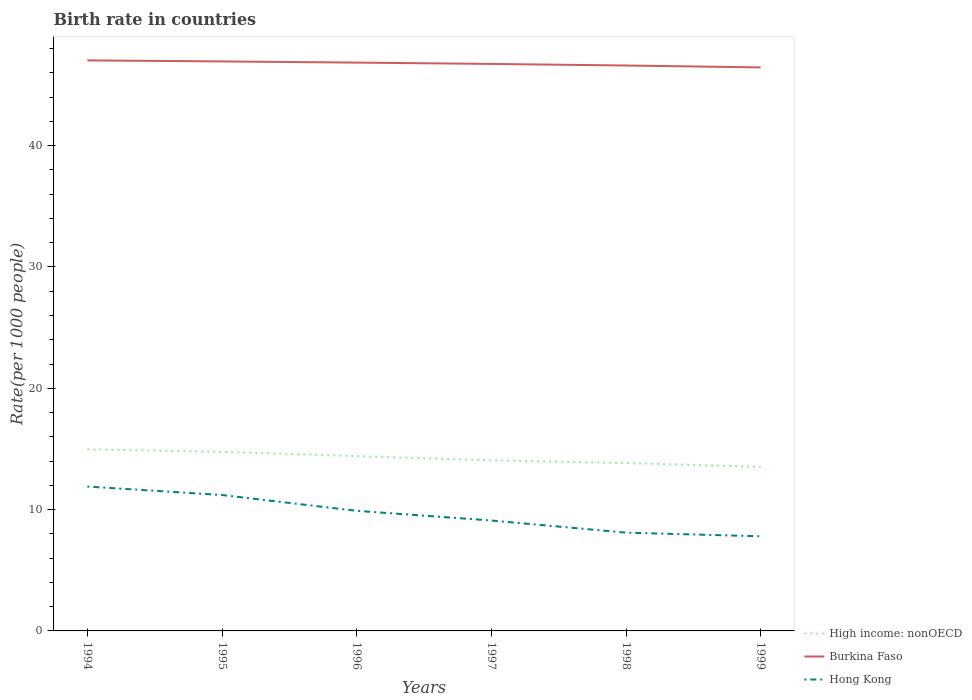How many different coloured lines are there?
Ensure brevity in your answer.  3. Does the line corresponding to Burkina Faso intersect with the line corresponding to High income: nonOECD?
Give a very brief answer. No. Is the number of lines equal to the number of legend labels?
Offer a terse response. Yes. What is the total birth rate in Hong Kong in the graph?
Provide a short and direct response. 1. What is the difference between the highest and the second highest birth rate in High income: nonOECD?
Offer a very short reply. 1.44. What is the difference between the highest and the lowest birth rate in High income: nonOECD?
Provide a succinct answer. 3. Is the birth rate in Hong Kong strictly greater than the birth rate in High income: nonOECD over the years?
Keep it short and to the point. Yes. How many lines are there?
Give a very brief answer. 3. Are the values on the major ticks of Y-axis written in scientific E-notation?
Keep it short and to the point. No. Does the graph contain any zero values?
Keep it short and to the point. No. Does the graph contain grids?
Keep it short and to the point. No. How many legend labels are there?
Provide a succinct answer. 3. How are the legend labels stacked?
Give a very brief answer. Vertical. What is the title of the graph?
Offer a very short reply. Birth rate in countries. What is the label or title of the X-axis?
Offer a very short reply. Years. What is the label or title of the Y-axis?
Make the answer very short. Rate(per 1000 people). What is the Rate(per 1000 people) of High income: nonOECD in 1994?
Offer a very short reply. 14.96. What is the Rate(per 1000 people) in Burkina Faso in 1994?
Give a very brief answer. 47.03. What is the Rate(per 1000 people) of Hong Kong in 1994?
Make the answer very short. 11.9. What is the Rate(per 1000 people) of High income: nonOECD in 1995?
Your answer should be compact. 14.76. What is the Rate(per 1000 people) of Burkina Faso in 1995?
Ensure brevity in your answer.  46.94. What is the Rate(per 1000 people) in High income: nonOECD in 1996?
Provide a succinct answer. 14.41. What is the Rate(per 1000 people) of Burkina Faso in 1996?
Your answer should be very brief. 46.84. What is the Rate(per 1000 people) in High income: nonOECD in 1997?
Make the answer very short. 14.06. What is the Rate(per 1000 people) in Burkina Faso in 1997?
Give a very brief answer. 46.73. What is the Rate(per 1000 people) in High income: nonOECD in 1998?
Keep it short and to the point. 13.84. What is the Rate(per 1000 people) of Burkina Faso in 1998?
Provide a short and direct response. 46.6. What is the Rate(per 1000 people) in Hong Kong in 1998?
Make the answer very short. 8.1. What is the Rate(per 1000 people) in High income: nonOECD in 1999?
Your answer should be very brief. 13.52. What is the Rate(per 1000 people) in Burkina Faso in 1999?
Make the answer very short. 46.45. Across all years, what is the maximum Rate(per 1000 people) of High income: nonOECD?
Keep it short and to the point. 14.96. Across all years, what is the maximum Rate(per 1000 people) in Burkina Faso?
Your answer should be very brief. 47.03. Across all years, what is the minimum Rate(per 1000 people) of High income: nonOECD?
Provide a succinct answer. 13.52. Across all years, what is the minimum Rate(per 1000 people) of Burkina Faso?
Ensure brevity in your answer.  46.45. What is the total Rate(per 1000 people) of High income: nonOECD in the graph?
Your answer should be compact. 85.56. What is the total Rate(per 1000 people) in Burkina Faso in the graph?
Ensure brevity in your answer.  280.59. What is the difference between the Rate(per 1000 people) of High income: nonOECD in 1994 and that in 1995?
Provide a succinct answer. 0.2. What is the difference between the Rate(per 1000 people) of Burkina Faso in 1994 and that in 1995?
Provide a succinct answer. 0.09. What is the difference between the Rate(per 1000 people) in High income: nonOECD in 1994 and that in 1996?
Keep it short and to the point. 0.55. What is the difference between the Rate(per 1000 people) in Burkina Faso in 1994 and that in 1996?
Your answer should be very brief. 0.18. What is the difference between the Rate(per 1000 people) of High income: nonOECD in 1994 and that in 1997?
Offer a very short reply. 0.9. What is the difference between the Rate(per 1000 people) in Burkina Faso in 1994 and that in 1997?
Offer a very short reply. 0.29. What is the difference between the Rate(per 1000 people) in Hong Kong in 1994 and that in 1997?
Ensure brevity in your answer.  2.8. What is the difference between the Rate(per 1000 people) in High income: nonOECD in 1994 and that in 1998?
Provide a short and direct response. 1.13. What is the difference between the Rate(per 1000 people) of Burkina Faso in 1994 and that in 1998?
Your answer should be compact. 0.42. What is the difference between the Rate(per 1000 people) of Hong Kong in 1994 and that in 1998?
Ensure brevity in your answer.  3.8. What is the difference between the Rate(per 1000 people) in High income: nonOECD in 1994 and that in 1999?
Provide a succinct answer. 1.44. What is the difference between the Rate(per 1000 people) of Burkina Faso in 1994 and that in 1999?
Give a very brief answer. 0.58. What is the difference between the Rate(per 1000 people) in High income: nonOECD in 1995 and that in 1996?
Your answer should be compact. 0.35. What is the difference between the Rate(per 1000 people) of Burkina Faso in 1995 and that in 1996?
Give a very brief answer. 0.1. What is the difference between the Rate(per 1000 people) in Hong Kong in 1995 and that in 1996?
Provide a short and direct response. 1.3. What is the difference between the Rate(per 1000 people) in High income: nonOECD in 1995 and that in 1997?
Provide a short and direct response. 0.7. What is the difference between the Rate(per 1000 people) in Burkina Faso in 1995 and that in 1997?
Ensure brevity in your answer.  0.21. What is the difference between the Rate(per 1000 people) in High income: nonOECD in 1995 and that in 1998?
Provide a succinct answer. 0.92. What is the difference between the Rate(per 1000 people) in Burkina Faso in 1995 and that in 1998?
Your response must be concise. 0.34. What is the difference between the Rate(per 1000 people) in High income: nonOECD in 1995 and that in 1999?
Offer a very short reply. 1.24. What is the difference between the Rate(per 1000 people) of Burkina Faso in 1995 and that in 1999?
Offer a terse response. 0.49. What is the difference between the Rate(per 1000 people) of High income: nonOECD in 1996 and that in 1997?
Your answer should be compact. 0.35. What is the difference between the Rate(per 1000 people) of Burkina Faso in 1996 and that in 1997?
Your response must be concise. 0.11. What is the difference between the Rate(per 1000 people) of Hong Kong in 1996 and that in 1997?
Keep it short and to the point. 0.8. What is the difference between the Rate(per 1000 people) in High income: nonOECD in 1996 and that in 1998?
Offer a terse response. 0.57. What is the difference between the Rate(per 1000 people) of Burkina Faso in 1996 and that in 1998?
Offer a very short reply. 0.24. What is the difference between the Rate(per 1000 people) in High income: nonOECD in 1996 and that in 1999?
Offer a terse response. 0.88. What is the difference between the Rate(per 1000 people) in Burkina Faso in 1996 and that in 1999?
Your answer should be compact. 0.4. What is the difference between the Rate(per 1000 people) of High income: nonOECD in 1997 and that in 1998?
Give a very brief answer. 0.22. What is the difference between the Rate(per 1000 people) in Burkina Faso in 1997 and that in 1998?
Make the answer very short. 0.13. What is the difference between the Rate(per 1000 people) in High income: nonOECD in 1997 and that in 1999?
Keep it short and to the point. 0.54. What is the difference between the Rate(per 1000 people) of Burkina Faso in 1997 and that in 1999?
Provide a succinct answer. 0.29. What is the difference between the Rate(per 1000 people) of High income: nonOECD in 1998 and that in 1999?
Keep it short and to the point. 0.31. What is the difference between the Rate(per 1000 people) of Burkina Faso in 1998 and that in 1999?
Give a very brief answer. 0.16. What is the difference between the Rate(per 1000 people) in Hong Kong in 1998 and that in 1999?
Offer a terse response. 0.3. What is the difference between the Rate(per 1000 people) in High income: nonOECD in 1994 and the Rate(per 1000 people) in Burkina Faso in 1995?
Make the answer very short. -31.98. What is the difference between the Rate(per 1000 people) in High income: nonOECD in 1994 and the Rate(per 1000 people) in Hong Kong in 1995?
Ensure brevity in your answer.  3.76. What is the difference between the Rate(per 1000 people) of Burkina Faso in 1994 and the Rate(per 1000 people) of Hong Kong in 1995?
Your answer should be compact. 35.83. What is the difference between the Rate(per 1000 people) in High income: nonOECD in 1994 and the Rate(per 1000 people) in Burkina Faso in 1996?
Your answer should be compact. -31.88. What is the difference between the Rate(per 1000 people) in High income: nonOECD in 1994 and the Rate(per 1000 people) in Hong Kong in 1996?
Ensure brevity in your answer.  5.06. What is the difference between the Rate(per 1000 people) in Burkina Faso in 1994 and the Rate(per 1000 people) in Hong Kong in 1996?
Provide a short and direct response. 37.13. What is the difference between the Rate(per 1000 people) in High income: nonOECD in 1994 and the Rate(per 1000 people) in Burkina Faso in 1997?
Ensure brevity in your answer.  -31.77. What is the difference between the Rate(per 1000 people) of High income: nonOECD in 1994 and the Rate(per 1000 people) of Hong Kong in 1997?
Offer a terse response. 5.86. What is the difference between the Rate(per 1000 people) in Burkina Faso in 1994 and the Rate(per 1000 people) in Hong Kong in 1997?
Ensure brevity in your answer.  37.93. What is the difference between the Rate(per 1000 people) of High income: nonOECD in 1994 and the Rate(per 1000 people) of Burkina Faso in 1998?
Ensure brevity in your answer.  -31.64. What is the difference between the Rate(per 1000 people) in High income: nonOECD in 1994 and the Rate(per 1000 people) in Hong Kong in 1998?
Offer a very short reply. 6.86. What is the difference between the Rate(per 1000 people) in Burkina Faso in 1994 and the Rate(per 1000 people) in Hong Kong in 1998?
Provide a succinct answer. 38.93. What is the difference between the Rate(per 1000 people) in High income: nonOECD in 1994 and the Rate(per 1000 people) in Burkina Faso in 1999?
Give a very brief answer. -31.48. What is the difference between the Rate(per 1000 people) of High income: nonOECD in 1994 and the Rate(per 1000 people) of Hong Kong in 1999?
Your answer should be compact. 7.16. What is the difference between the Rate(per 1000 people) of Burkina Faso in 1994 and the Rate(per 1000 people) of Hong Kong in 1999?
Ensure brevity in your answer.  39.23. What is the difference between the Rate(per 1000 people) of High income: nonOECD in 1995 and the Rate(per 1000 people) of Burkina Faso in 1996?
Your answer should be compact. -32.08. What is the difference between the Rate(per 1000 people) of High income: nonOECD in 1995 and the Rate(per 1000 people) of Hong Kong in 1996?
Provide a short and direct response. 4.86. What is the difference between the Rate(per 1000 people) in Burkina Faso in 1995 and the Rate(per 1000 people) in Hong Kong in 1996?
Keep it short and to the point. 37.04. What is the difference between the Rate(per 1000 people) in High income: nonOECD in 1995 and the Rate(per 1000 people) in Burkina Faso in 1997?
Your answer should be compact. -31.97. What is the difference between the Rate(per 1000 people) in High income: nonOECD in 1995 and the Rate(per 1000 people) in Hong Kong in 1997?
Your answer should be compact. 5.66. What is the difference between the Rate(per 1000 people) in Burkina Faso in 1995 and the Rate(per 1000 people) in Hong Kong in 1997?
Keep it short and to the point. 37.84. What is the difference between the Rate(per 1000 people) in High income: nonOECD in 1995 and the Rate(per 1000 people) in Burkina Faso in 1998?
Keep it short and to the point. -31.84. What is the difference between the Rate(per 1000 people) in High income: nonOECD in 1995 and the Rate(per 1000 people) in Hong Kong in 1998?
Offer a terse response. 6.66. What is the difference between the Rate(per 1000 people) in Burkina Faso in 1995 and the Rate(per 1000 people) in Hong Kong in 1998?
Offer a very short reply. 38.84. What is the difference between the Rate(per 1000 people) of High income: nonOECD in 1995 and the Rate(per 1000 people) of Burkina Faso in 1999?
Ensure brevity in your answer.  -31.68. What is the difference between the Rate(per 1000 people) of High income: nonOECD in 1995 and the Rate(per 1000 people) of Hong Kong in 1999?
Provide a short and direct response. 6.96. What is the difference between the Rate(per 1000 people) in Burkina Faso in 1995 and the Rate(per 1000 people) in Hong Kong in 1999?
Ensure brevity in your answer.  39.14. What is the difference between the Rate(per 1000 people) of High income: nonOECD in 1996 and the Rate(per 1000 people) of Burkina Faso in 1997?
Your response must be concise. -32.32. What is the difference between the Rate(per 1000 people) in High income: nonOECD in 1996 and the Rate(per 1000 people) in Hong Kong in 1997?
Your answer should be very brief. 5.31. What is the difference between the Rate(per 1000 people) in Burkina Faso in 1996 and the Rate(per 1000 people) in Hong Kong in 1997?
Ensure brevity in your answer.  37.74. What is the difference between the Rate(per 1000 people) in High income: nonOECD in 1996 and the Rate(per 1000 people) in Burkina Faso in 1998?
Ensure brevity in your answer.  -32.19. What is the difference between the Rate(per 1000 people) in High income: nonOECD in 1996 and the Rate(per 1000 people) in Hong Kong in 1998?
Make the answer very short. 6.31. What is the difference between the Rate(per 1000 people) in Burkina Faso in 1996 and the Rate(per 1000 people) in Hong Kong in 1998?
Offer a terse response. 38.74. What is the difference between the Rate(per 1000 people) in High income: nonOECD in 1996 and the Rate(per 1000 people) in Burkina Faso in 1999?
Your response must be concise. -32.04. What is the difference between the Rate(per 1000 people) of High income: nonOECD in 1996 and the Rate(per 1000 people) of Hong Kong in 1999?
Keep it short and to the point. 6.61. What is the difference between the Rate(per 1000 people) in Burkina Faso in 1996 and the Rate(per 1000 people) in Hong Kong in 1999?
Offer a very short reply. 39.04. What is the difference between the Rate(per 1000 people) of High income: nonOECD in 1997 and the Rate(per 1000 people) of Burkina Faso in 1998?
Offer a terse response. -32.54. What is the difference between the Rate(per 1000 people) of High income: nonOECD in 1997 and the Rate(per 1000 people) of Hong Kong in 1998?
Your answer should be compact. 5.96. What is the difference between the Rate(per 1000 people) in Burkina Faso in 1997 and the Rate(per 1000 people) in Hong Kong in 1998?
Provide a succinct answer. 38.63. What is the difference between the Rate(per 1000 people) of High income: nonOECD in 1997 and the Rate(per 1000 people) of Burkina Faso in 1999?
Keep it short and to the point. -32.38. What is the difference between the Rate(per 1000 people) of High income: nonOECD in 1997 and the Rate(per 1000 people) of Hong Kong in 1999?
Offer a terse response. 6.26. What is the difference between the Rate(per 1000 people) in Burkina Faso in 1997 and the Rate(per 1000 people) in Hong Kong in 1999?
Offer a terse response. 38.93. What is the difference between the Rate(per 1000 people) in High income: nonOECD in 1998 and the Rate(per 1000 people) in Burkina Faso in 1999?
Keep it short and to the point. -32.61. What is the difference between the Rate(per 1000 people) in High income: nonOECD in 1998 and the Rate(per 1000 people) in Hong Kong in 1999?
Offer a very short reply. 6.04. What is the difference between the Rate(per 1000 people) of Burkina Faso in 1998 and the Rate(per 1000 people) of Hong Kong in 1999?
Your answer should be compact. 38.8. What is the average Rate(per 1000 people) in High income: nonOECD per year?
Give a very brief answer. 14.26. What is the average Rate(per 1000 people) in Burkina Faso per year?
Ensure brevity in your answer.  46.76. What is the average Rate(per 1000 people) in Hong Kong per year?
Offer a very short reply. 9.67. In the year 1994, what is the difference between the Rate(per 1000 people) in High income: nonOECD and Rate(per 1000 people) in Burkina Faso?
Provide a short and direct response. -32.06. In the year 1994, what is the difference between the Rate(per 1000 people) in High income: nonOECD and Rate(per 1000 people) in Hong Kong?
Provide a succinct answer. 3.06. In the year 1994, what is the difference between the Rate(per 1000 people) in Burkina Faso and Rate(per 1000 people) in Hong Kong?
Ensure brevity in your answer.  35.13. In the year 1995, what is the difference between the Rate(per 1000 people) in High income: nonOECD and Rate(per 1000 people) in Burkina Faso?
Make the answer very short. -32.18. In the year 1995, what is the difference between the Rate(per 1000 people) of High income: nonOECD and Rate(per 1000 people) of Hong Kong?
Provide a succinct answer. 3.56. In the year 1995, what is the difference between the Rate(per 1000 people) in Burkina Faso and Rate(per 1000 people) in Hong Kong?
Keep it short and to the point. 35.74. In the year 1996, what is the difference between the Rate(per 1000 people) of High income: nonOECD and Rate(per 1000 people) of Burkina Faso?
Provide a succinct answer. -32.43. In the year 1996, what is the difference between the Rate(per 1000 people) in High income: nonOECD and Rate(per 1000 people) in Hong Kong?
Keep it short and to the point. 4.51. In the year 1996, what is the difference between the Rate(per 1000 people) in Burkina Faso and Rate(per 1000 people) in Hong Kong?
Your response must be concise. 36.94. In the year 1997, what is the difference between the Rate(per 1000 people) of High income: nonOECD and Rate(per 1000 people) of Burkina Faso?
Ensure brevity in your answer.  -32.67. In the year 1997, what is the difference between the Rate(per 1000 people) of High income: nonOECD and Rate(per 1000 people) of Hong Kong?
Your response must be concise. 4.96. In the year 1997, what is the difference between the Rate(per 1000 people) in Burkina Faso and Rate(per 1000 people) in Hong Kong?
Give a very brief answer. 37.63. In the year 1998, what is the difference between the Rate(per 1000 people) in High income: nonOECD and Rate(per 1000 people) in Burkina Faso?
Provide a short and direct response. -32.77. In the year 1998, what is the difference between the Rate(per 1000 people) in High income: nonOECD and Rate(per 1000 people) in Hong Kong?
Your response must be concise. 5.74. In the year 1998, what is the difference between the Rate(per 1000 people) of Burkina Faso and Rate(per 1000 people) of Hong Kong?
Offer a terse response. 38.5. In the year 1999, what is the difference between the Rate(per 1000 people) in High income: nonOECD and Rate(per 1000 people) in Burkina Faso?
Ensure brevity in your answer.  -32.92. In the year 1999, what is the difference between the Rate(per 1000 people) in High income: nonOECD and Rate(per 1000 people) in Hong Kong?
Make the answer very short. 5.72. In the year 1999, what is the difference between the Rate(per 1000 people) in Burkina Faso and Rate(per 1000 people) in Hong Kong?
Offer a very short reply. 38.65. What is the ratio of the Rate(per 1000 people) of High income: nonOECD in 1994 to that in 1995?
Provide a succinct answer. 1.01. What is the ratio of the Rate(per 1000 people) of Burkina Faso in 1994 to that in 1996?
Keep it short and to the point. 1. What is the ratio of the Rate(per 1000 people) of Hong Kong in 1994 to that in 1996?
Your answer should be very brief. 1.2. What is the ratio of the Rate(per 1000 people) of High income: nonOECD in 1994 to that in 1997?
Offer a terse response. 1.06. What is the ratio of the Rate(per 1000 people) of Hong Kong in 1994 to that in 1997?
Your response must be concise. 1.31. What is the ratio of the Rate(per 1000 people) in High income: nonOECD in 1994 to that in 1998?
Provide a short and direct response. 1.08. What is the ratio of the Rate(per 1000 people) in Burkina Faso in 1994 to that in 1998?
Ensure brevity in your answer.  1.01. What is the ratio of the Rate(per 1000 people) in Hong Kong in 1994 to that in 1998?
Offer a terse response. 1.47. What is the ratio of the Rate(per 1000 people) in High income: nonOECD in 1994 to that in 1999?
Your response must be concise. 1.11. What is the ratio of the Rate(per 1000 people) of Burkina Faso in 1994 to that in 1999?
Make the answer very short. 1.01. What is the ratio of the Rate(per 1000 people) in Hong Kong in 1994 to that in 1999?
Ensure brevity in your answer.  1.53. What is the ratio of the Rate(per 1000 people) of High income: nonOECD in 1995 to that in 1996?
Provide a succinct answer. 1.02. What is the ratio of the Rate(per 1000 people) in Hong Kong in 1995 to that in 1996?
Keep it short and to the point. 1.13. What is the ratio of the Rate(per 1000 people) in High income: nonOECD in 1995 to that in 1997?
Offer a terse response. 1.05. What is the ratio of the Rate(per 1000 people) in Hong Kong in 1995 to that in 1997?
Ensure brevity in your answer.  1.23. What is the ratio of the Rate(per 1000 people) in High income: nonOECD in 1995 to that in 1998?
Your response must be concise. 1.07. What is the ratio of the Rate(per 1000 people) of Burkina Faso in 1995 to that in 1998?
Keep it short and to the point. 1.01. What is the ratio of the Rate(per 1000 people) of Hong Kong in 1995 to that in 1998?
Make the answer very short. 1.38. What is the ratio of the Rate(per 1000 people) in High income: nonOECD in 1995 to that in 1999?
Offer a terse response. 1.09. What is the ratio of the Rate(per 1000 people) of Burkina Faso in 1995 to that in 1999?
Make the answer very short. 1.01. What is the ratio of the Rate(per 1000 people) in Hong Kong in 1995 to that in 1999?
Your answer should be very brief. 1.44. What is the ratio of the Rate(per 1000 people) of High income: nonOECD in 1996 to that in 1997?
Give a very brief answer. 1.02. What is the ratio of the Rate(per 1000 people) of Burkina Faso in 1996 to that in 1997?
Your answer should be compact. 1. What is the ratio of the Rate(per 1000 people) of Hong Kong in 1996 to that in 1997?
Ensure brevity in your answer.  1.09. What is the ratio of the Rate(per 1000 people) of High income: nonOECD in 1996 to that in 1998?
Offer a very short reply. 1.04. What is the ratio of the Rate(per 1000 people) in Hong Kong in 1996 to that in 1998?
Your answer should be compact. 1.22. What is the ratio of the Rate(per 1000 people) in High income: nonOECD in 1996 to that in 1999?
Provide a succinct answer. 1.07. What is the ratio of the Rate(per 1000 people) in Burkina Faso in 1996 to that in 1999?
Your answer should be compact. 1.01. What is the ratio of the Rate(per 1000 people) in Hong Kong in 1996 to that in 1999?
Keep it short and to the point. 1.27. What is the ratio of the Rate(per 1000 people) in High income: nonOECD in 1997 to that in 1998?
Give a very brief answer. 1.02. What is the ratio of the Rate(per 1000 people) of Hong Kong in 1997 to that in 1998?
Offer a very short reply. 1.12. What is the ratio of the Rate(per 1000 people) in High income: nonOECD in 1997 to that in 1999?
Your response must be concise. 1.04. What is the ratio of the Rate(per 1000 people) of Burkina Faso in 1997 to that in 1999?
Ensure brevity in your answer.  1.01. What is the ratio of the Rate(per 1000 people) in Hong Kong in 1997 to that in 1999?
Offer a very short reply. 1.17. What is the ratio of the Rate(per 1000 people) of High income: nonOECD in 1998 to that in 1999?
Your answer should be very brief. 1.02. What is the difference between the highest and the second highest Rate(per 1000 people) of High income: nonOECD?
Provide a succinct answer. 0.2. What is the difference between the highest and the second highest Rate(per 1000 people) in Burkina Faso?
Give a very brief answer. 0.09. What is the difference between the highest and the lowest Rate(per 1000 people) in High income: nonOECD?
Give a very brief answer. 1.44. What is the difference between the highest and the lowest Rate(per 1000 people) in Burkina Faso?
Make the answer very short. 0.58. 